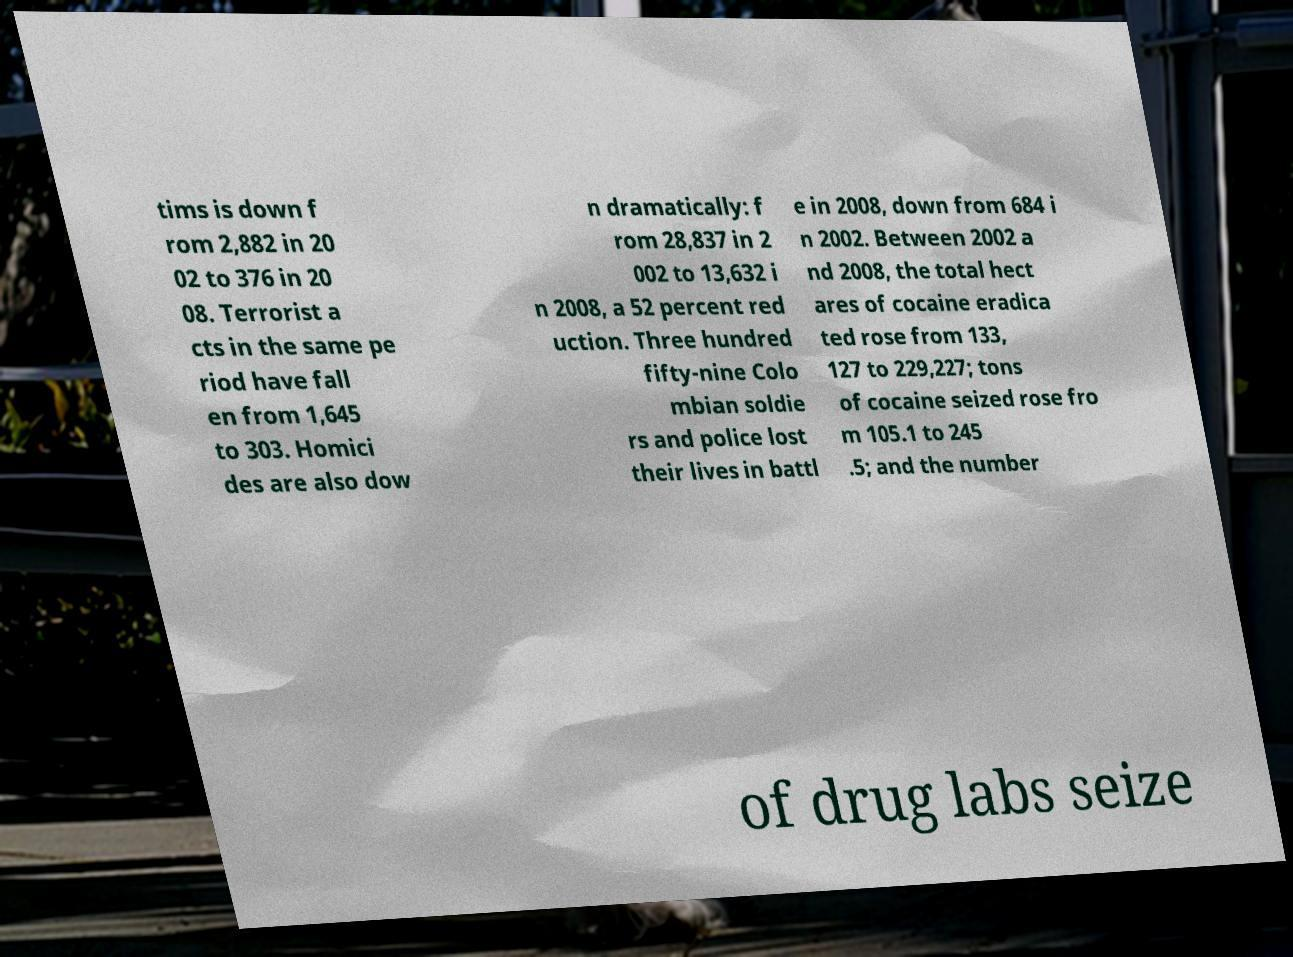For documentation purposes, I need the text within this image transcribed. Could you provide that? tims is down f rom 2,882 in 20 02 to 376 in 20 08. Terrorist a cts in the same pe riod have fall en from 1,645 to 303. Homici des are also dow n dramatically: f rom 28,837 in 2 002 to 13,632 i n 2008, a 52 percent red uction. Three hundred fifty-nine Colo mbian soldie rs and police lost their lives in battl e in 2008, down from 684 i n 2002. Between 2002 a nd 2008, the total hect ares of cocaine eradica ted rose from 133, 127 to 229,227; tons of cocaine seized rose fro m 105.1 to 245 .5; and the number of drug labs seize 